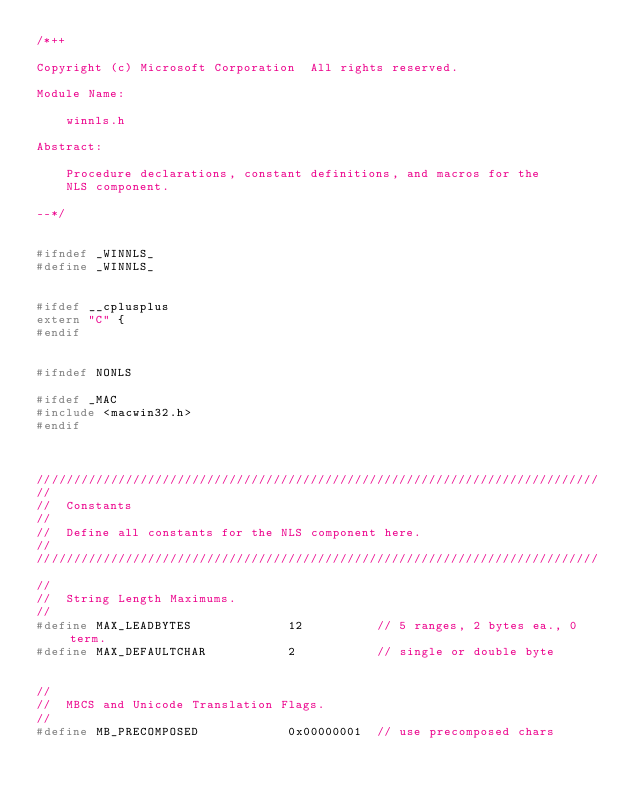<code> <loc_0><loc_0><loc_500><loc_500><_C_>/*++

Copyright (c) Microsoft Corporation  All rights reserved.

Module Name:

    winnls.h

Abstract:

    Procedure declarations, constant definitions, and macros for the
    NLS component.

--*/


#ifndef _WINNLS_
#define _WINNLS_


#ifdef __cplusplus
extern "C" {
#endif


#ifndef NONLS

#ifdef _MAC
#include <macwin32.h>
#endif



////////////////////////////////////////////////////////////////////////////
//
//  Constants
//
//  Define all constants for the NLS component here.
//
////////////////////////////////////////////////////////////////////////////

//
//  String Length Maximums.
//
#define MAX_LEADBYTES             12          // 5 ranges, 2 bytes ea., 0 term.
#define MAX_DEFAULTCHAR           2           // single or double byte


//
//  MBCS and Unicode Translation Flags.
//
#define MB_PRECOMPOSED            0x00000001  // use precomposed chars</code> 